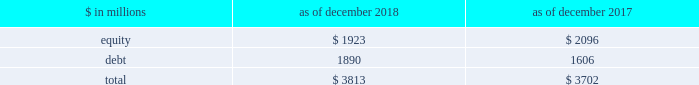The goldman sachs group , inc .
And subsidiaries management 2019s discussion and analysis during periods in which we have significantly more positive net revenue days than net revenue loss days , we expect to have fewer var exceptions because , under normal conditions , our business model generally produces positive net revenues .
In periods in which our franchise revenues are adversely affected , we generally have more loss days , resulting in more var exceptions .
The daily net revenues for positions included in var used to determine var exceptions reflect the impact of any intraday activity , including bid/offer net revenues , which are more likely than not to be positive by their nature .
Sensitivity measures certain portfolios and individual positions are not included in var because var is not the most appropriate risk measure .
Other sensitivity measures we use to analyze market risk are described below .
10% ( 10 % ) sensitivity measures .
The table below presents market risk by asset category for positions accounted for at fair value , that are not included in var. .
In the table above : 2030 the market risk of these positions is determined by estimating the potential reduction in net revenues of a 10% ( 10 % ) decline in the value of these positions .
2030 equity positions relate to private and restricted public equity securities , including interests in funds that invest in corporate equities and real estate and interests in hedge funds .
2030 debt positions include interests in funds that invest in corporate mezzanine and senior debt instruments , loans backed by commercial and residential real estate , corporate bank loans and other corporate debt , including acquired portfolios of distressed loans .
2030 funded equity and debt positions are included in our consolidated statements of financial condition in financial instruments owned .
See note 6 to the consolidated financial statements for further information about cash instruments .
2030 these measures do not reflect the diversification effect across asset categories or across other market risk measures .
Credit spread sensitivity on derivatives and financial liabilities .
Var excludes the impact of changes in counterparty and our own credit spreads on derivatives , as well as changes in our own credit spreads ( debt valuation adjustment ) on financial liabilities for which the fair value option was elected .
The estimated sensitivity to a one basis point increase in credit spreads ( counterparty and our own ) on derivatives was a gain of $ 3 million ( including hedges ) as of both december 2018 and december 2017 .
In addition , the estimated sensitivity to a one basis point increase in our own credit spreads on financial liabilities for which the fair value option was elected was a gain of $ 41 million as of december 2018 and $ 35 million as of december 2017 .
However , the actual net impact of a change in our own credit spreads is also affected by the liquidity , duration and convexity ( as the sensitivity is not linear to changes in yields ) of those financial liabilities for which the fair value option was elected , as well as the relative performance of any hedges undertaken .
Interest rate sensitivity .
Loans receivable were $ 80.59 billion as of december 2018 and $ 65.93 billion as of december 2017 , substantially all of which had floating interest rates .
The estimated sensitivity to a 100 basis point increase in interest rates on such loans was $ 607 million as of december 2018 and $ 527 million as of december 2017 , of additional interest income over a twelve-month period , which does not take into account the potential impact of an increase in costs to fund such loans .
See note 9 to the consolidated financial statements for further information about loans receivable .
Other market risk considerations as of both december 2018 and december 2017 , we had commitments and held loans for which we have obtained credit loss protection from sumitomo mitsui financial group , inc .
See note 18 to the consolidated financial statements for further information about such lending commitments .
In addition , we make investments in securities that are accounted for as available-for-sale and included in financial instruments owned in the consolidated statements of financial condition .
See note 6 to the consolidated financial statements for further information .
We also make investments accounted for under the equity method and we also make direct investments in real estate , both of which are included in other assets .
Direct investments in real estate are accounted for at cost less accumulated depreciation .
See note 13 to the consolidated financial statements for further information about other assets .
92 goldman sachs 2018 form 10-k .
For asset category for positions accounted for at fair value , that are not included in var , in millions for 2018 and 2017 , what was the maximum equity value? 
Computations: table_max(equity, none)
Answer: 2096.0. 